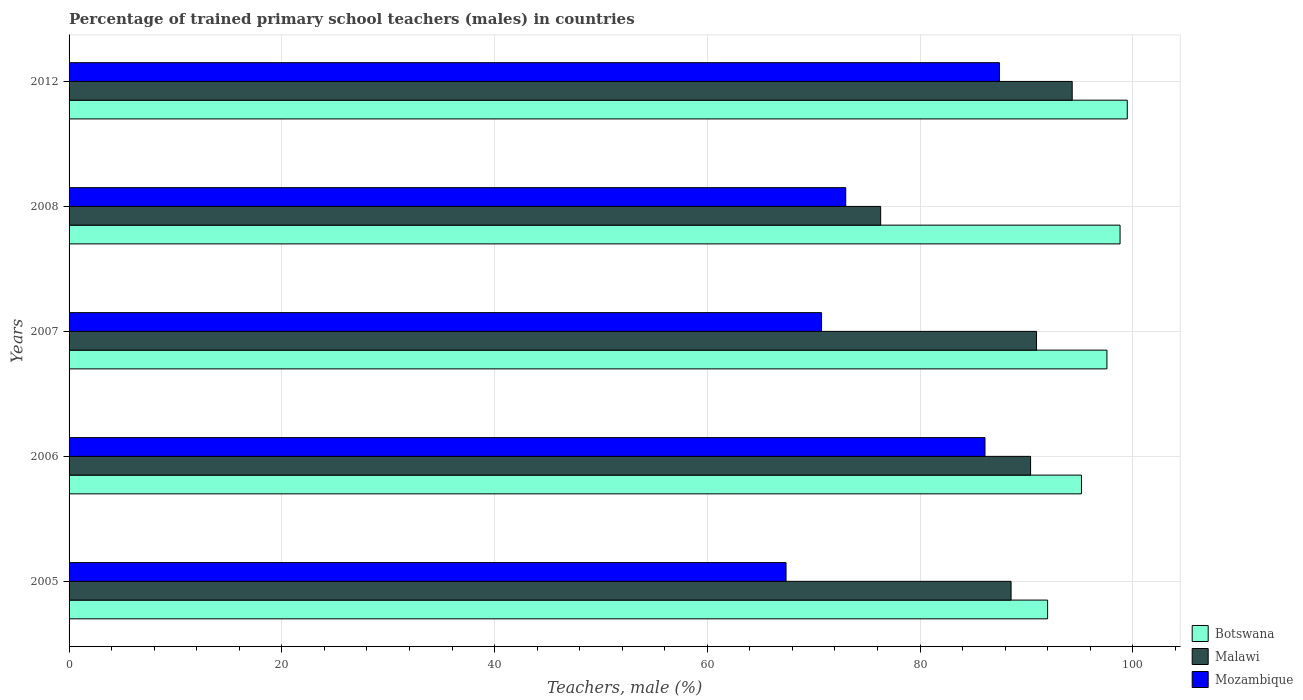How many groups of bars are there?
Offer a very short reply. 5. Are the number of bars per tick equal to the number of legend labels?
Make the answer very short. Yes. How many bars are there on the 4th tick from the top?
Offer a terse response. 3. What is the percentage of trained primary school teachers (males) in Mozambique in 2008?
Your response must be concise. 73.01. Across all years, what is the maximum percentage of trained primary school teachers (males) in Mozambique?
Make the answer very short. 87.46. Across all years, what is the minimum percentage of trained primary school teachers (males) in Malawi?
Ensure brevity in your answer.  76.3. In which year was the percentage of trained primary school teachers (males) in Botswana maximum?
Provide a succinct answer. 2012. What is the total percentage of trained primary school teachers (males) in Malawi in the graph?
Offer a very short reply. 440.5. What is the difference between the percentage of trained primary school teachers (males) in Botswana in 2007 and that in 2012?
Give a very brief answer. -1.91. What is the difference between the percentage of trained primary school teachers (males) in Botswana in 2005 and the percentage of trained primary school teachers (males) in Mozambique in 2012?
Your response must be concise. 4.53. What is the average percentage of trained primary school teachers (males) in Botswana per year?
Your response must be concise. 96.6. In the year 2007, what is the difference between the percentage of trained primary school teachers (males) in Malawi and percentage of trained primary school teachers (males) in Mozambique?
Your answer should be very brief. 20.21. In how many years, is the percentage of trained primary school teachers (males) in Botswana greater than 4 %?
Ensure brevity in your answer.  5. What is the ratio of the percentage of trained primary school teachers (males) in Mozambique in 2005 to that in 2006?
Give a very brief answer. 0.78. Is the difference between the percentage of trained primary school teachers (males) in Malawi in 2005 and 2012 greater than the difference between the percentage of trained primary school teachers (males) in Mozambique in 2005 and 2012?
Your answer should be compact. Yes. What is the difference between the highest and the second highest percentage of trained primary school teachers (males) in Malawi?
Your answer should be compact. 3.35. What is the difference between the highest and the lowest percentage of trained primary school teachers (males) in Malawi?
Ensure brevity in your answer.  18.01. In how many years, is the percentage of trained primary school teachers (males) in Botswana greater than the average percentage of trained primary school teachers (males) in Botswana taken over all years?
Give a very brief answer. 3. What does the 2nd bar from the top in 2012 represents?
Ensure brevity in your answer.  Malawi. What does the 3rd bar from the bottom in 2012 represents?
Ensure brevity in your answer.  Mozambique. Are all the bars in the graph horizontal?
Make the answer very short. Yes. How many years are there in the graph?
Your answer should be very brief. 5. What is the difference between two consecutive major ticks on the X-axis?
Make the answer very short. 20. Does the graph contain any zero values?
Your response must be concise. No. Does the graph contain grids?
Keep it short and to the point. Yes. Where does the legend appear in the graph?
Make the answer very short. Bottom right. How many legend labels are there?
Your answer should be compact. 3. What is the title of the graph?
Your response must be concise. Percentage of trained primary school teachers (males) in countries. Does "Australia" appear as one of the legend labels in the graph?
Your response must be concise. No. What is the label or title of the X-axis?
Keep it short and to the point. Teachers, male (%). What is the label or title of the Y-axis?
Make the answer very short. Years. What is the Teachers, male (%) of Botswana in 2005?
Offer a very short reply. 91.99. What is the Teachers, male (%) in Malawi in 2005?
Offer a very short reply. 88.56. What is the Teachers, male (%) of Mozambique in 2005?
Give a very brief answer. 67.4. What is the Teachers, male (%) in Botswana in 2006?
Offer a very short reply. 95.17. What is the Teachers, male (%) of Malawi in 2006?
Provide a short and direct response. 90.39. What is the Teachers, male (%) in Mozambique in 2006?
Offer a very short reply. 86.1. What is the Teachers, male (%) of Botswana in 2007?
Keep it short and to the point. 97.57. What is the Teachers, male (%) in Malawi in 2007?
Offer a terse response. 90.95. What is the Teachers, male (%) of Mozambique in 2007?
Provide a succinct answer. 70.74. What is the Teachers, male (%) of Botswana in 2008?
Provide a succinct answer. 98.8. What is the Teachers, male (%) in Malawi in 2008?
Keep it short and to the point. 76.3. What is the Teachers, male (%) in Mozambique in 2008?
Provide a short and direct response. 73.01. What is the Teachers, male (%) of Botswana in 2012?
Your answer should be compact. 99.48. What is the Teachers, male (%) in Malawi in 2012?
Your response must be concise. 94.3. What is the Teachers, male (%) of Mozambique in 2012?
Your answer should be very brief. 87.46. Across all years, what is the maximum Teachers, male (%) of Botswana?
Keep it short and to the point. 99.48. Across all years, what is the maximum Teachers, male (%) in Malawi?
Provide a succinct answer. 94.3. Across all years, what is the maximum Teachers, male (%) in Mozambique?
Provide a succinct answer. 87.46. Across all years, what is the minimum Teachers, male (%) in Botswana?
Ensure brevity in your answer.  91.99. Across all years, what is the minimum Teachers, male (%) of Malawi?
Ensure brevity in your answer.  76.3. Across all years, what is the minimum Teachers, male (%) of Mozambique?
Offer a very short reply. 67.4. What is the total Teachers, male (%) of Botswana in the graph?
Ensure brevity in your answer.  483.02. What is the total Teachers, male (%) of Malawi in the graph?
Provide a succinct answer. 440.5. What is the total Teachers, male (%) of Mozambique in the graph?
Your response must be concise. 384.72. What is the difference between the Teachers, male (%) in Botswana in 2005 and that in 2006?
Provide a short and direct response. -3.18. What is the difference between the Teachers, male (%) in Malawi in 2005 and that in 2006?
Offer a very short reply. -1.83. What is the difference between the Teachers, male (%) of Mozambique in 2005 and that in 2006?
Offer a very short reply. -18.7. What is the difference between the Teachers, male (%) in Botswana in 2005 and that in 2007?
Provide a succinct answer. -5.58. What is the difference between the Teachers, male (%) of Malawi in 2005 and that in 2007?
Ensure brevity in your answer.  -2.39. What is the difference between the Teachers, male (%) in Mozambique in 2005 and that in 2007?
Make the answer very short. -3.34. What is the difference between the Teachers, male (%) in Botswana in 2005 and that in 2008?
Make the answer very short. -6.81. What is the difference between the Teachers, male (%) of Malawi in 2005 and that in 2008?
Your answer should be very brief. 12.26. What is the difference between the Teachers, male (%) of Mozambique in 2005 and that in 2008?
Provide a succinct answer. -5.61. What is the difference between the Teachers, male (%) of Botswana in 2005 and that in 2012?
Offer a terse response. -7.49. What is the difference between the Teachers, male (%) of Malawi in 2005 and that in 2012?
Provide a succinct answer. -5.75. What is the difference between the Teachers, male (%) in Mozambique in 2005 and that in 2012?
Make the answer very short. -20.06. What is the difference between the Teachers, male (%) of Botswana in 2006 and that in 2007?
Your answer should be compact. -2.39. What is the difference between the Teachers, male (%) of Malawi in 2006 and that in 2007?
Ensure brevity in your answer.  -0.56. What is the difference between the Teachers, male (%) of Mozambique in 2006 and that in 2007?
Your answer should be very brief. 15.36. What is the difference between the Teachers, male (%) in Botswana in 2006 and that in 2008?
Your answer should be compact. -3.63. What is the difference between the Teachers, male (%) in Malawi in 2006 and that in 2008?
Ensure brevity in your answer.  14.09. What is the difference between the Teachers, male (%) in Mozambique in 2006 and that in 2008?
Ensure brevity in your answer.  13.09. What is the difference between the Teachers, male (%) in Botswana in 2006 and that in 2012?
Your response must be concise. -4.31. What is the difference between the Teachers, male (%) of Malawi in 2006 and that in 2012?
Ensure brevity in your answer.  -3.91. What is the difference between the Teachers, male (%) of Mozambique in 2006 and that in 2012?
Offer a very short reply. -1.36. What is the difference between the Teachers, male (%) of Botswana in 2007 and that in 2008?
Provide a succinct answer. -1.23. What is the difference between the Teachers, male (%) in Malawi in 2007 and that in 2008?
Provide a short and direct response. 14.65. What is the difference between the Teachers, male (%) of Mozambique in 2007 and that in 2008?
Offer a terse response. -2.27. What is the difference between the Teachers, male (%) in Botswana in 2007 and that in 2012?
Offer a very short reply. -1.91. What is the difference between the Teachers, male (%) of Malawi in 2007 and that in 2012?
Your response must be concise. -3.35. What is the difference between the Teachers, male (%) in Mozambique in 2007 and that in 2012?
Provide a short and direct response. -16.72. What is the difference between the Teachers, male (%) of Botswana in 2008 and that in 2012?
Provide a short and direct response. -0.68. What is the difference between the Teachers, male (%) of Malawi in 2008 and that in 2012?
Ensure brevity in your answer.  -18.01. What is the difference between the Teachers, male (%) of Mozambique in 2008 and that in 2012?
Provide a short and direct response. -14.45. What is the difference between the Teachers, male (%) in Botswana in 2005 and the Teachers, male (%) in Malawi in 2006?
Offer a very short reply. 1.6. What is the difference between the Teachers, male (%) in Botswana in 2005 and the Teachers, male (%) in Mozambique in 2006?
Keep it short and to the point. 5.89. What is the difference between the Teachers, male (%) of Malawi in 2005 and the Teachers, male (%) of Mozambique in 2006?
Offer a terse response. 2.45. What is the difference between the Teachers, male (%) in Botswana in 2005 and the Teachers, male (%) in Malawi in 2007?
Offer a terse response. 1.04. What is the difference between the Teachers, male (%) in Botswana in 2005 and the Teachers, male (%) in Mozambique in 2007?
Your response must be concise. 21.25. What is the difference between the Teachers, male (%) in Malawi in 2005 and the Teachers, male (%) in Mozambique in 2007?
Ensure brevity in your answer.  17.82. What is the difference between the Teachers, male (%) of Botswana in 2005 and the Teachers, male (%) of Malawi in 2008?
Offer a very short reply. 15.7. What is the difference between the Teachers, male (%) in Botswana in 2005 and the Teachers, male (%) in Mozambique in 2008?
Make the answer very short. 18.98. What is the difference between the Teachers, male (%) of Malawi in 2005 and the Teachers, male (%) of Mozambique in 2008?
Your answer should be compact. 15.54. What is the difference between the Teachers, male (%) of Botswana in 2005 and the Teachers, male (%) of Malawi in 2012?
Make the answer very short. -2.31. What is the difference between the Teachers, male (%) of Botswana in 2005 and the Teachers, male (%) of Mozambique in 2012?
Make the answer very short. 4.53. What is the difference between the Teachers, male (%) of Malawi in 2005 and the Teachers, male (%) of Mozambique in 2012?
Provide a short and direct response. 1.09. What is the difference between the Teachers, male (%) of Botswana in 2006 and the Teachers, male (%) of Malawi in 2007?
Make the answer very short. 4.23. What is the difference between the Teachers, male (%) of Botswana in 2006 and the Teachers, male (%) of Mozambique in 2007?
Offer a very short reply. 24.43. What is the difference between the Teachers, male (%) in Malawi in 2006 and the Teachers, male (%) in Mozambique in 2007?
Make the answer very short. 19.65. What is the difference between the Teachers, male (%) in Botswana in 2006 and the Teachers, male (%) in Malawi in 2008?
Give a very brief answer. 18.88. What is the difference between the Teachers, male (%) in Botswana in 2006 and the Teachers, male (%) in Mozambique in 2008?
Offer a terse response. 22.16. What is the difference between the Teachers, male (%) in Malawi in 2006 and the Teachers, male (%) in Mozambique in 2008?
Keep it short and to the point. 17.38. What is the difference between the Teachers, male (%) in Botswana in 2006 and the Teachers, male (%) in Malawi in 2012?
Your answer should be compact. 0.87. What is the difference between the Teachers, male (%) of Botswana in 2006 and the Teachers, male (%) of Mozambique in 2012?
Ensure brevity in your answer.  7.71. What is the difference between the Teachers, male (%) in Malawi in 2006 and the Teachers, male (%) in Mozambique in 2012?
Your answer should be compact. 2.93. What is the difference between the Teachers, male (%) in Botswana in 2007 and the Teachers, male (%) in Malawi in 2008?
Give a very brief answer. 21.27. What is the difference between the Teachers, male (%) in Botswana in 2007 and the Teachers, male (%) in Mozambique in 2008?
Keep it short and to the point. 24.55. What is the difference between the Teachers, male (%) in Malawi in 2007 and the Teachers, male (%) in Mozambique in 2008?
Ensure brevity in your answer.  17.94. What is the difference between the Teachers, male (%) of Botswana in 2007 and the Teachers, male (%) of Malawi in 2012?
Keep it short and to the point. 3.27. What is the difference between the Teachers, male (%) in Botswana in 2007 and the Teachers, male (%) in Mozambique in 2012?
Your response must be concise. 10.11. What is the difference between the Teachers, male (%) in Malawi in 2007 and the Teachers, male (%) in Mozambique in 2012?
Your response must be concise. 3.49. What is the difference between the Teachers, male (%) of Botswana in 2008 and the Teachers, male (%) of Malawi in 2012?
Ensure brevity in your answer.  4.5. What is the difference between the Teachers, male (%) in Botswana in 2008 and the Teachers, male (%) in Mozambique in 2012?
Your answer should be compact. 11.34. What is the difference between the Teachers, male (%) in Malawi in 2008 and the Teachers, male (%) in Mozambique in 2012?
Keep it short and to the point. -11.17. What is the average Teachers, male (%) of Botswana per year?
Your answer should be compact. 96.6. What is the average Teachers, male (%) in Malawi per year?
Your answer should be compact. 88.1. What is the average Teachers, male (%) of Mozambique per year?
Offer a very short reply. 76.94. In the year 2005, what is the difference between the Teachers, male (%) in Botswana and Teachers, male (%) in Malawi?
Your answer should be compact. 3.43. In the year 2005, what is the difference between the Teachers, male (%) of Botswana and Teachers, male (%) of Mozambique?
Provide a short and direct response. 24.59. In the year 2005, what is the difference between the Teachers, male (%) in Malawi and Teachers, male (%) in Mozambique?
Your answer should be very brief. 21.16. In the year 2006, what is the difference between the Teachers, male (%) in Botswana and Teachers, male (%) in Malawi?
Your answer should be very brief. 4.78. In the year 2006, what is the difference between the Teachers, male (%) in Botswana and Teachers, male (%) in Mozambique?
Offer a very short reply. 9.07. In the year 2006, what is the difference between the Teachers, male (%) of Malawi and Teachers, male (%) of Mozambique?
Give a very brief answer. 4.29. In the year 2007, what is the difference between the Teachers, male (%) in Botswana and Teachers, male (%) in Malawi?
Your response must be concise. 6.62. In the year 2007, what is the difference between the Teachers, male (%) of Botswana and Teachers, male (%) of Mozambique?
Make the answer very short. 26.83. In the year 2007, what is the difference between the Teachers, male (%) in Malawi and Teachers, male (%) in Mozambique?
Give a very brief answer. 20.21. In the year 2008, what is the difference between the Teachers, male (%) of Botswana and Teachers, male (%) of Malawi?
Your response must be concise. 22.51. In the year 2008, what is the difference between the Teachers, male (%) of Botswana and Teachers, male (%) of Mozambique?
Keep it short and to the point. 25.79. In the year 2008, what is the difference between the Teachers, male (%) in Malawi and Teachers, male (%) in Mozambique?
Your answer should be compact. 3.28. In the year 2012, what is the difference between the Teachers, male (%) of Botswana and Teachers, male (%) of Malawi?
Keep it short and to the point. 5.18. In the year 2012, what is the difference between the Teachers, male (%) of Botswana and Teachers, male (%) of Mozambique?
Keep it short and to the point. 12.02. In the year 2012, what is the difference between the Teachers, male (%) in Malawi and Teachers, male (%) in Mozambique?
Keep it short and to the point. 6.84. What is the ratio of the Teachers, male (%) in Botswana in 2005 to that in 2006?
Your response must be concise. 0.97. What is the ratio of the Teachers, male (%) of Malawi in 2005 to that in 2006?
Your answer should be compact. 0.98. What is the ratio of the Teachers, male (%) of Mozambique in 2005 to that in 2006?
Your response must be concise. 0.78. What is the ratio of the Teachers, male (%) in Botswana in 2005 to that in 2007?
Your response must be concise. 0.94. What is the ratio of the Teachers, male (%) of Malawi in 2005 to that in 2007?
Make the answer very short. 0.97. What is the ratio of the Teachers, male (%) in Mozambique in 2005 to that in 2007?
Your response must be concise. 0.95. What is the ratio of the Teachers, male (%) of Botswana in 2005 to that in 2008?
Your response must be concise. 0.93. What is the ratio of the Teachers, male (%) of Malawi in 2005 to that in 2008?
Keep it short and to the point. 1.16. What is the ratio of the Teachers, male (%) of Botswana in 2005 to that in 2012?
Offer a very short reply. 0.92. What is the ratio of the Teachers, male (%) in Malawi in 2005 to that in 2012?
Offer a very short reply. 0.94. What is the ratio of the Teachers, male (%) in Mozambique in 2005 to that in 2012?
Provide a succinct answer. 0.77. What is the ratio of the Teachers, male (%) of Botswana in 2006 to that in 2007?
Ensure brevity in your answer.  0.98. What is the ratio of the Teachers, male (%) in Malawi in 2006 to that in 2007?
Ensure brevity in your answer.  0.99. What is the ratio of the Teachers, male (%) in Mozambique in 2006 to that in 2007?
Offer a terse response. 1.22. What is the ratio of the Teachers, male (%) in Botswana in 2006 to that in 2008?
Make the answer very short. 0.96. What is the ratio of the Teachers, male (%) of Malawi in 2006 to that in 2008?
Provide a succinct answer. 1.18. What is the ratio of the Teachers, male (%) of Mozambique in 2006 to that in 2008?
Your answer should be compact. 1.18. What is the ratio of the Teachers, male (%) in Botswana in 2006 to that in 2012?
Offer a terse response. 0.96. What is the ratio of the Teachers, male (%) of Malawi in 2006 to that in 2012?
Make the answer very short. 0.96. What is the ratio of the Teachers, male (%) in Mozambique in 2006 to that in 2012?
Make the answer very short. 0.98. What is the ratio of the Teachers, male (%) of Botswana in 2007 to that in 2008?
Ensure brevity in your answer.  0.99. What is the ratio of the Teachers, male (%) of Malawi in 2007 to that in 2008?
Give a very brief answer. 1.19. What is the ratio of the Teachers, male (%) in Mozambique in 2007 to that in 2008?
Keep it short and to the point. 0.97. What is the ratio of the Teachers, male (%) in Botswana in 2007 to that in 2012?
Ensure brevity in your answer.  0.98. What is the ratio of the Teachers, male (%) of Malawi in 2007 to that in 2012?
Your answer should be compact. 0.96. What is the ratio of the Teachers, male (%) of Mozambique in 2007 to that in 2012?
Your response must be concise. 0.81. What is the ratio of the Teachers, male (%) in Botswana in 2008 to that in 2012?
Give a very brief answer. 0.99. What is the ratio of the Teachers, male (%) of Malawi in 2008 to that in 2012?
Ensure brevity in your answer.  0.81. What is the ratio of the Teachers, male (%) of Mozambique in 2008 to that in 2012?
Offer a terse response. 0.83. What is the difference between the highest and the second highest Teachers, male (%) in Botswana?
Provide a short and direct response. 0.68. What is the difference between the highest and the second highest Teachers, male (%) of Malawi?
Your response must be concise. 3.35. What is the difference between the highest and the second highest Teachers, male (%) of Mozambique?
Give a very brief answer. 1.36. What is the difference between the highest and the lowest Teachers, male (%) in Botswana?
Provide a succinct answer. 7.49. What is the difference between the highest and the lowest Teachers, male (%) in Malawi?
Provide a succinct answer. 18.01. What is the difference between the highest and the lowest Teachers, male (%) in Mozambique?
Your answer should be compact. 20.06. 